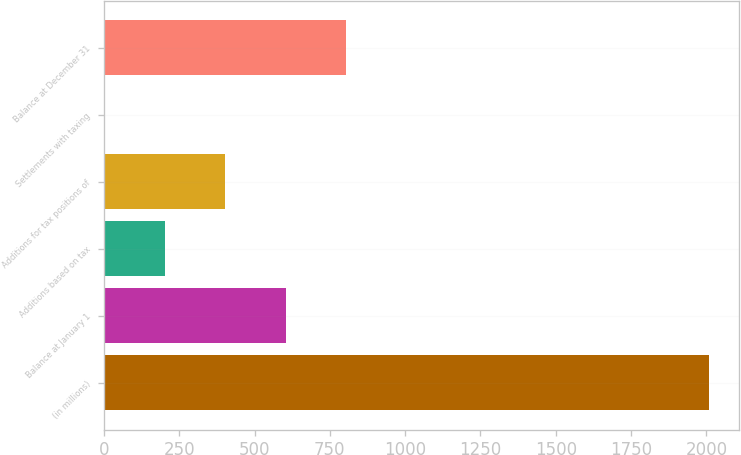Convert chart to OTSL. <chart><loc_0><loc_0><loc_500><loc_500><bar_chart><fcel>(in millions)<fcel>Balance at January 1<fcel>Additions based on tax<fcel>Additions for tax positions of<fcel>Settlements with taxing<fcel>Balance at December 31<nl><fcel>2008<fcel>603.24<fcel>201.88<fcel>402.56<fcel>1.2<fcel>803.92<nl></chart> 